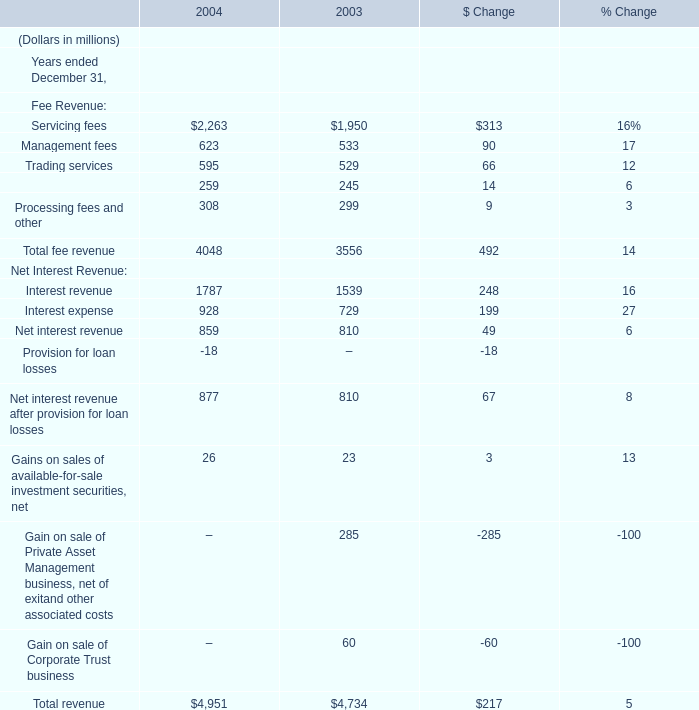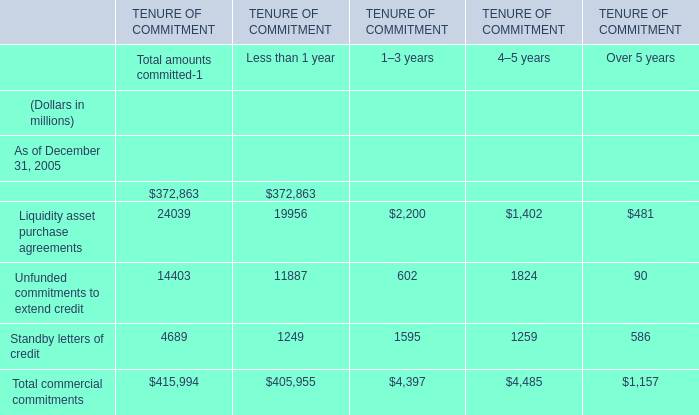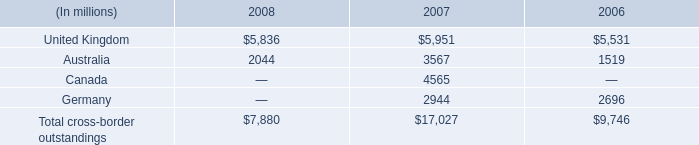What is the growing rate of Interest revenue in the year with the most total fee revenue? (in %) 
Computations: ((1787 - 1539) / 1539)
Answer: 0.16114. 